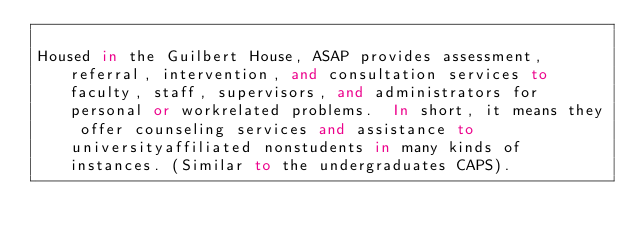Convert code to text. <code><loc_0><loc_0><loc_500><loc_500><_FORTRAN_>
Housed in the Guilbert House, ASAP provides assessment, referral, intervention, and consultation services to faculty, staff, supervisors, and administrators for personal or workrelated problems.  In short, it means they offer counseling services and assistance to universityaffiliated nonstudents in many kinds of instances. (Similar to the undergraduates CAPS).
</code> 